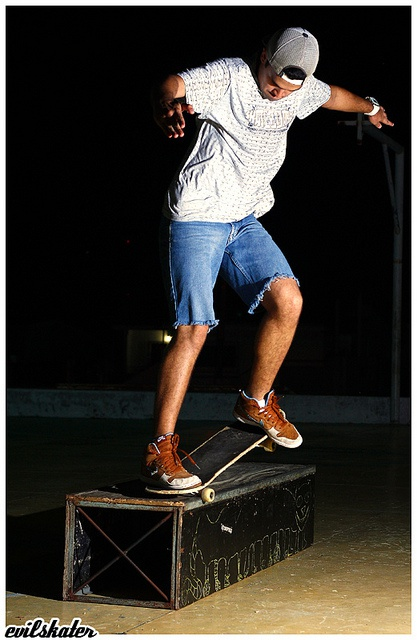Describe the objects in this image and their specific colors. I can see people in white, black, tan, and darkgray tones and skateboard in white, black, khaki, lightyellow, and maroon tones in this image. 